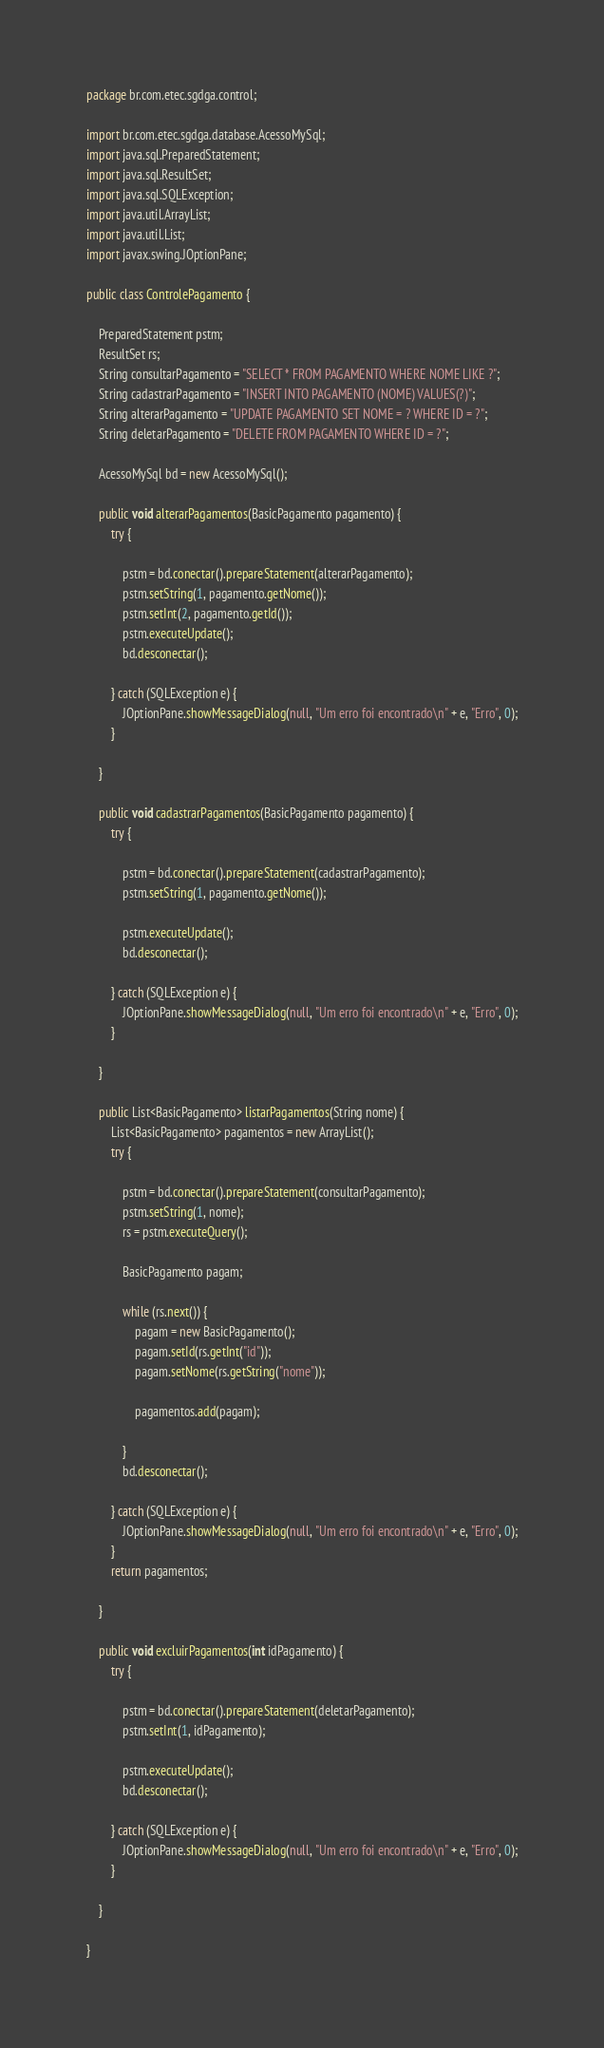Convert code to text. <code><loc_0><loc_0><loc_500><loc_500><_Java_>package br.com.etec.sgdga.control;

import br.com.etec.sgdga.database.AcessoMySql;
import java.sql.PreparedStatement;
import java.sql.ResultSet;
import java.sql.SQLException;
import java.util.ArrayList;
import java.util.List;
import javax.swing.JOptionPane;

public class ControlePagamento {

    PreparedStatement pstm;
    ResultSet rs;
    String consultarPagamento = "SELECT * FROM PAGAMENTO WHERE NOME LIKE ?";
    String cadastrarPagamento = "INSERT INTO PAGAMENTO (NOME) VALUES(?)";
    String alterarPagamento = "UPDATE PAGAMENTO SET NOME = ? WHERE ID = ?";
    String deletarPagamento = "DELETE FROM PAGAMENTO WHERE ID = ?";

    AcessoMySql bd = new AcessoMySql();

    public void alterarPagamentos(BasicPagamento pagamento) {
        try {

            pstm = bd.conectar().prepareStatement(alterarPagamento);
            pstm.setString(1, pagamento.getNome());
            pstm.setInt(2, pagamento.getId());
            pstm.executeUpdate();
            bd.desconectar();

        } catch (SQLException e) {
            JOptionPane.showMessageDialog(null, "Um erro foi encontrado\n" + e, "Erro", 0);
        }

    }

    public void cadastrarPagamentos(BasicPagamento pagamento) {
        try {

            pstm = bd.conectar().prepareStatement(cadastrarPagamento);
            pstm.setString(1, pagamento.getNome());

            pstm.executeUpdate();
            bd.desconectar();

        } catch (SQLException e) {
            JOptionPane.showMessageDialog(null, "Um erro foi encontrado\n" + e, "Erro", 0);
        }

    }

    public List<BasicPagamento> listarPagamentos(String nome) {
        List<BasicPagamento> pagamentos = new ArrayList();
        try {

            pstm = bd.conectar().prepareStatement(consultarPagamento);
            pstm.setString(1, nome);
            rs = pstm.executeQuery();

            BasicPagamento pagam;

            while (rs.next()) {
                pagam = new BasicPagamento();
                pagam.setId(rs.getInt("id"));
                pagam.setNome(rs.getString("nome"));

                pagamentos.add(pagam);

            }
            bd.desconectar();

        } catch (SQLException e) {
            JOptionPane.showMessageDialog(null, "Um erro foi encontrado\n" + e, "Erro", 0);
        }
        return pagamentos;

    }

    public void excluirPagamentos(int idPagamento) {
        try {

            pstm = bd.conectar().prepareStatement(deletarPagamento);
            pstm.setInt(1, idPagamento);

            pstm.executeUpdate();
            bd.desconectar();

        } catch (SQLException e) {
            JOptionPane.showMessageDialog(null, "Um erro foi encontrado\n" + e, "Erro", 0);
        }

    }

}
</code> 